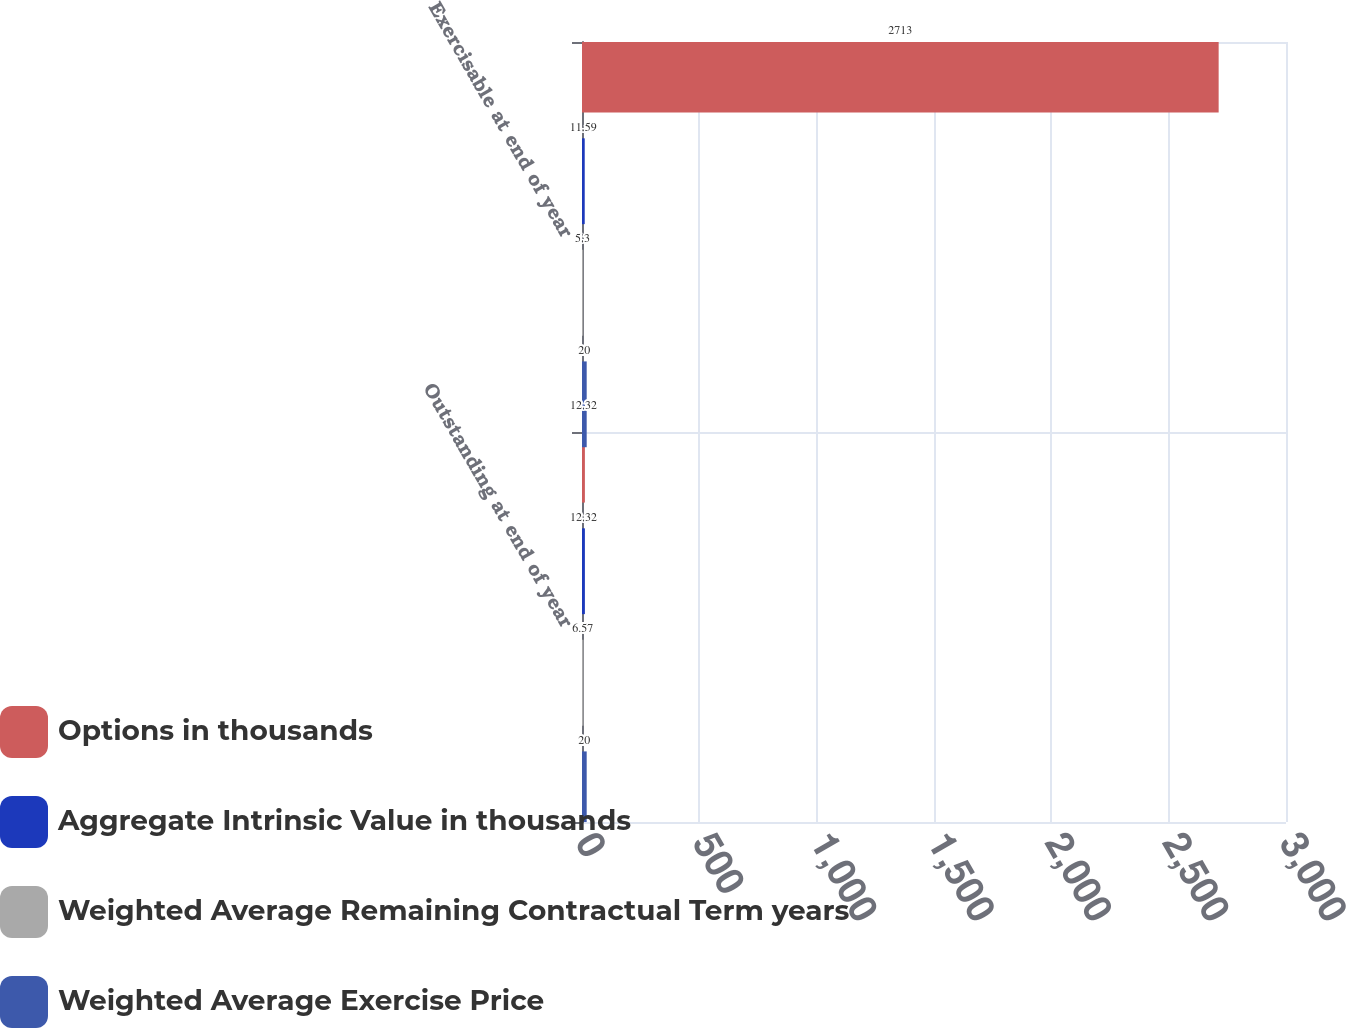Convert chart. <chart><loc_0><loc_0><loc_500><loc_500><stacked_bar_chart><ecel><fcel>Outstanding at end of year<fcel>Exercisable at end of year<nl><fcel>Options in thousands<fcel>12.32<fcel>2713<nl><fcel>Aggregate Intrinsic Value in thousands<fcel>12.32<fcel>11.59<nl><fcel>Weighted Average Remaining Contractual Term years<fcel>6.57<fcel>5.3<nl><fcel>Weighted Average Exercise Price<fcel>20<fcel>20<nl></chart> 